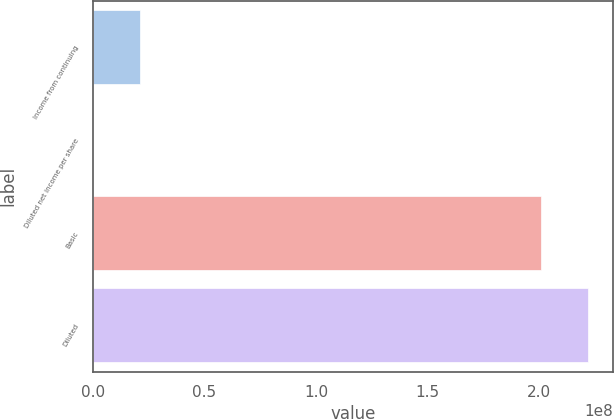Convert chart. <chart><loc_0><loc_0><loc_500><loc_500><bar_chart><fcel>Income from continuing<fcel>Diluted net income per share<fcel>Basic<fcel>Diluted<nl><fcel>2.09258e+07<fcel>0.72<fcel>2.00846e+08<fcel>2.21772e+08<nl></chart> 